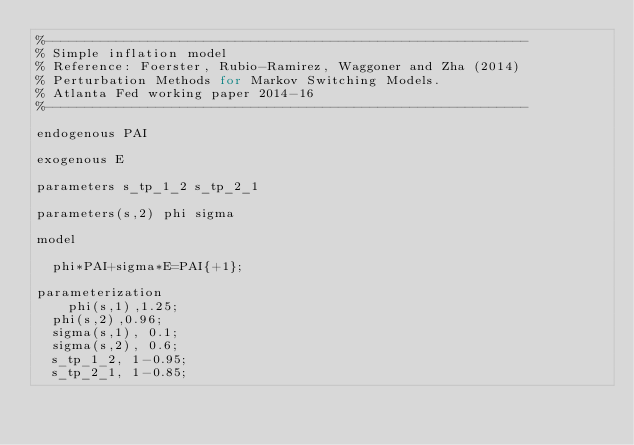<code> <loc_0><loc_0><loc_500><loc_500><_Rust_>%-------------------------------------------------------------
% Simple inflation model
% Reference: Foerster, Rubio-Ramirez, Waggoner and Zha (2014)
% Perturbation Methods for Markov Switching Models.
% Atlanta Fed working paper 2014-16
%-------------------------------------------------------------

endogenous PAI

exogenous E

parameters s_tp_1_2 s_tp_2_1

parameters(s,2) phi sigma

model

	phi*PAI+sigma*E=PAI{+1};

parameterization
    phi(s,1),1.25;
	phi(s,2),0.96;
	sigma(s,1), 0.1;
	sigma(s,2), 0.6;
	s_tp_1_2, 1-0.95;
	s_tp_2_1, 1-0.85;
	 </code> 